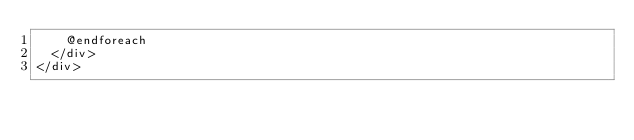Convert code to text. <code><loc_0><loc_0><loc_500><loc_500><_PHP_>    @endforeach
  </div>
</div>
</code> 